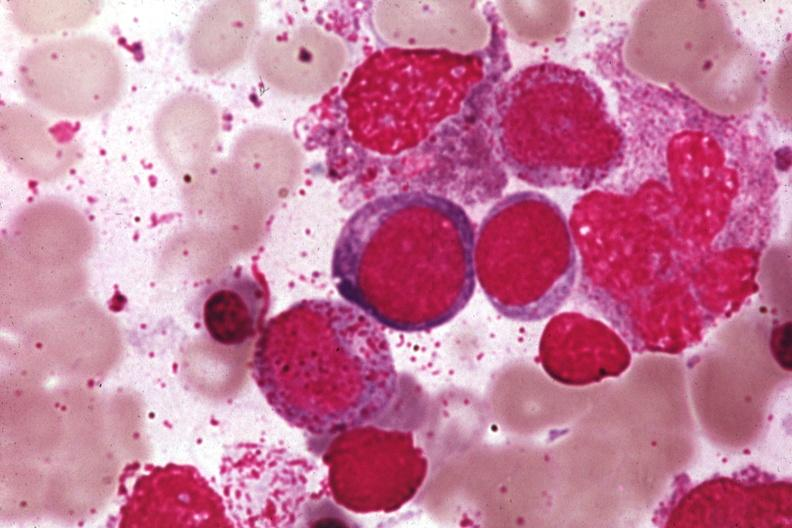what is present?
Answer the question using a single word or phrase. Hematologic 